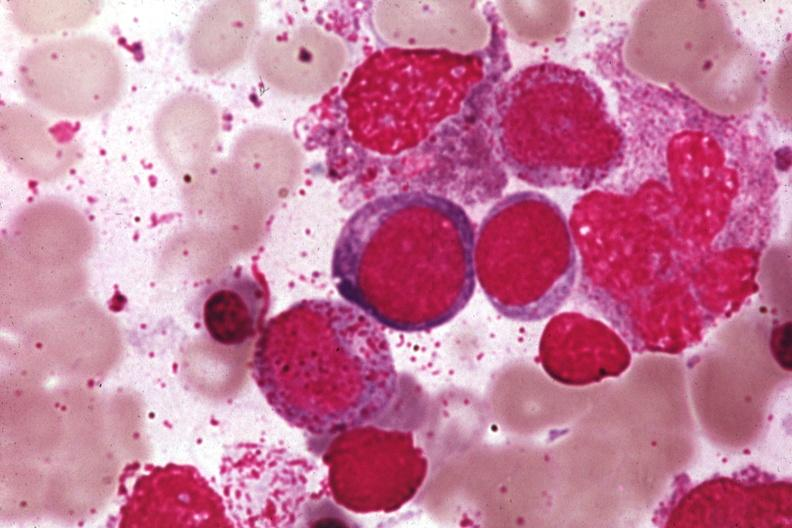what is present?
Answer the question using a single word or phrase. Hematologic 